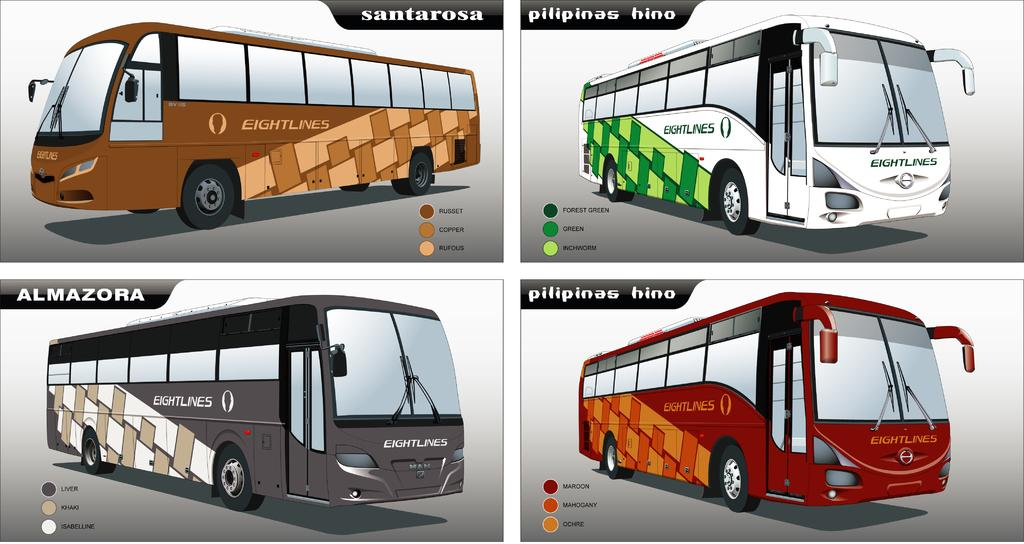What type of artwork is shown in the image? The image is a collage. What can be seen in the collage? The collage contains images of houses with different colors. Are there any words or phrases in the collage? Yes, there is text present in the collage. How does the artist sort the houses in the collage based on their size? The image does not provide information about the size of the houses, nor does it suggest any sorting based on size. 